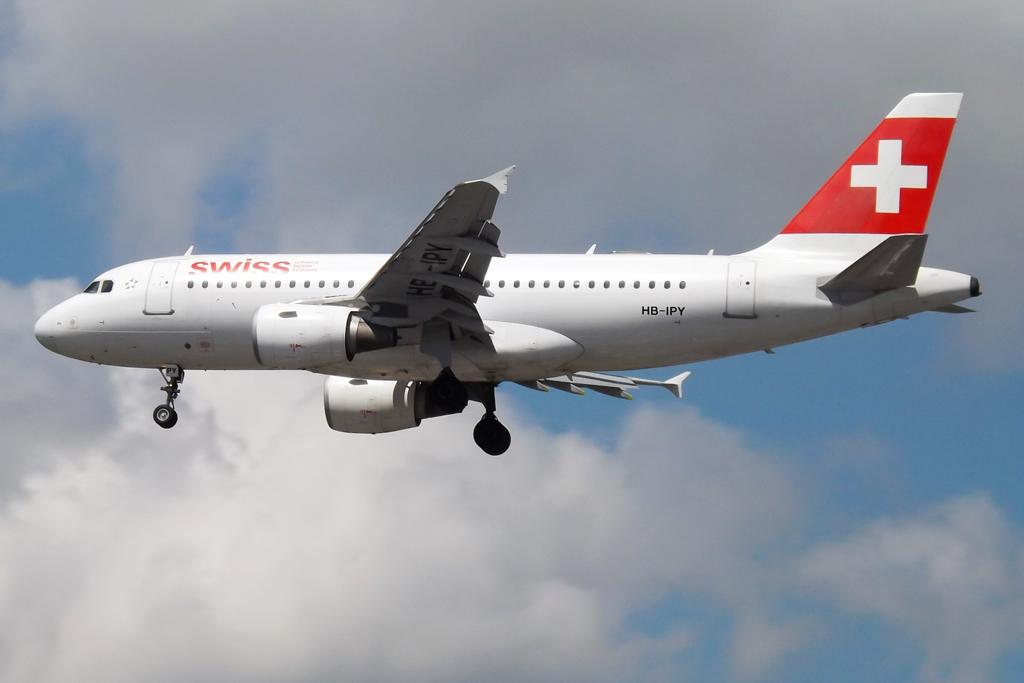What is the sponsor of the team?
Your response must be concise. Unanswerable. What brand airplane is this?
Your answer should be compact. Swiss. 